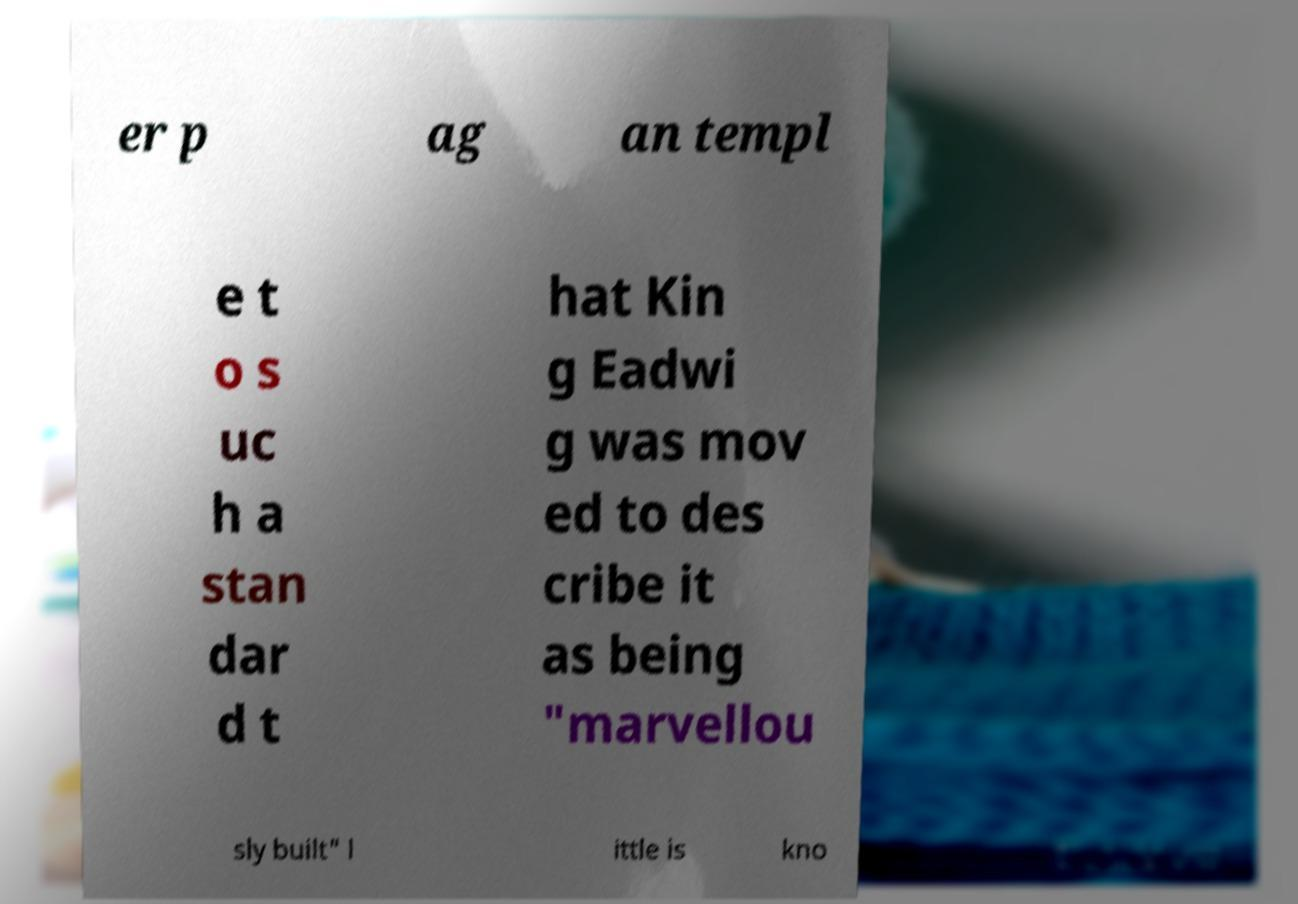Can you read and provide the text displayed in the image?This photo seems to have some interesting text. Can you extract and type it out for me? er p ag an templ e t o s uc h a stan dar d t hat Kin g Eadwi g was mov ed to des cribe it as being "marvellou sly built" l ittle is kno 